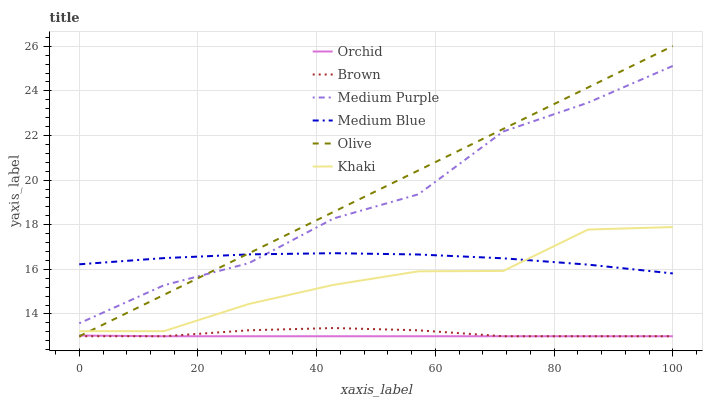Does Orchid have the minimum area under the curve?
Answer yes or no. Yes. Does Olive have the maximum area under the curve?
Answer yes or no. Yes. Does Khaki have the minimum area under the curve?
Answer yes or no. No. Does Khaki have the maximum area under the curve?
Answer yes or no. No. Is Olive the smoothest?
Answer yes or no. Yes. Is Medium Purple the roughest?
Answer yes or no. Yes. Is Khaki the smoothest?
Answer yes or no. No. Is Khaki the roughest?
Answer yes or no. No. Does Brown have the lowest value?
Answer yes or no. Yes. Does Khaki have the lowest value?
Answer yes or no. No. Does Olive have the highest value?
Answer yes or no. Yes. Does Khaki have the highest value?
Answer yes or no. No. Is Orchid less than Medium Blue?
Answer yes or no. Yes. Is Medium Purple greater than Brown?
Answer yes or no. Yes. Does Medium Blue intersect Medium Purple?
Answer yes or no. Yes. Is Medium Blue less than Medium Purple?
Answer yes or no. No. Is Medium Blue greater than Medium Purple?
Answer yes or no. No. Does Orchid intersect Medium Blue?
Answer yes or no. No. 